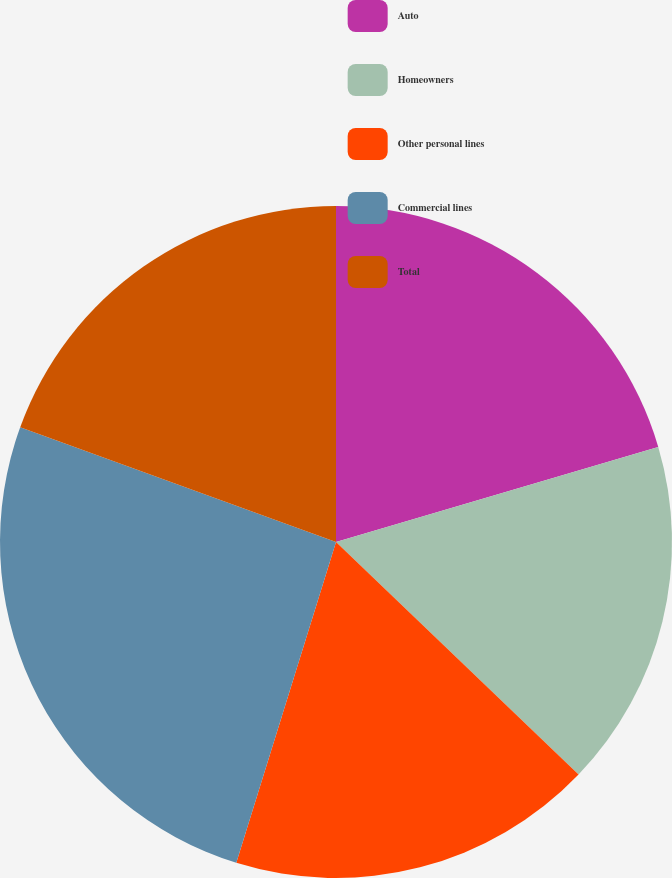Convert chart. <chart><loc_0><loc_0><loc_500><loc_500><pie_chart><fcel>Auto<fcel>Homeowners<fcel>Other personal lines<fcel>Commercial lines<fcel>Total<nl><fcel>20.43%<fcel>16.73%<fcel>17.63%<fcel>25.75%<fcel>19.45%<nl></chart> 